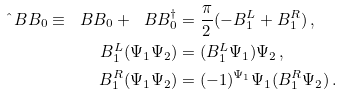Convert formula to latex. <formula><loc_0><loc_0><loc_500><loc_500>\hat { \ } B B _ { 0 } \equiv \ B B _ { 0 } + \ B B _ { 0 } ^ { \dagger } & = \frac { \pi } { 2 } ( - B _ { 1 } ^ { L } + B _ { 1 } ^ { R } ) \, , \\ B _ { 1 } ^ { L } ( \Psi _ { 1 } \Psi _ { 2 } ) & = ( B _ { 1 } ^ { L } \Psi _ { 1 } ) \Psi _ { 2 } \, , \\ B _ { 1 } ^ { R } ( \Psi _ { 1 } \Psi _ { 2 } ) & = ( - 1 ) ^ { \Psi _ { 1 } } \Psi _ { 1 } ( B _ { 1 } ^ { R } \Psi _ { 2 } ) \, .</formula> 